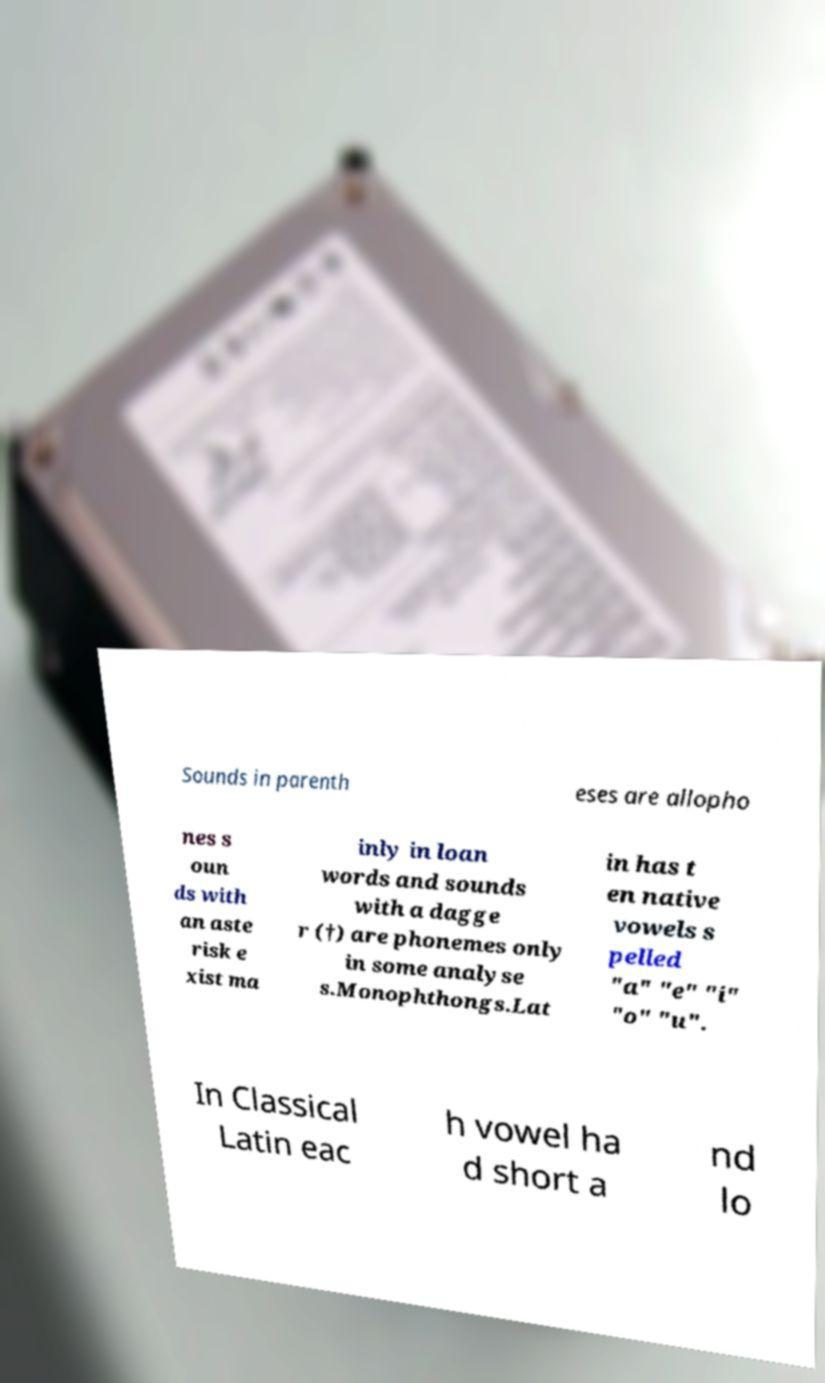Can you accurately transcribe the text from the provided image for me? Sounds in parenth eses are allopho nes s oun ds with an aste risk e xist ma inly in loan words and sounds with a dagge r (†) are phonemes only in some analyse s.Monophthongs.Lat in has t en native vowels s pelled "a" "e" "i" "o" "u". In Classical Latin eac h vowel ha d short a nd lo 